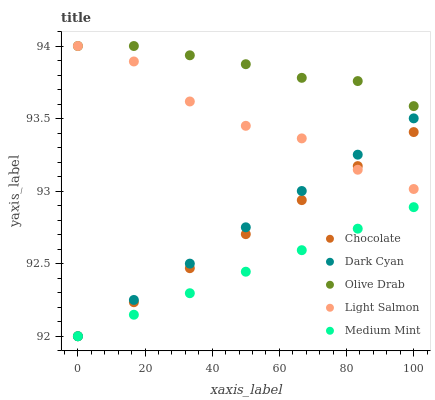Does Medium Mint have the minimum area under the curve?
Answer yes or no. Yes. Does Olive Drab have the maximum area under the curve?
Answer yes or no. Yes. Does Light Salmon have the minimum area under the curve?
Answer yes or no. No. Does Light Salmon have the maximum area under the curve?
Answer yes or no. No. Is Chocolate the smoothest?
Answer yes or no. Yes. Is Light Salmon the roughest?
Answer yes or no. Yes. Is Medium Mint the smoothest?
Answer yes or no. No. Is Medium Mint the roughest?
Answer yes or no. No. Does Dark Cyan have the lowest value?
Answer yes or no. Yes. Does Light Salmon have the lowest value?
Answer yes or no. No. Does Olive Drab have the highest value?
Answer yes or no. Yes. Does Medium Mint have the highest value?
Answer yes or no. No. Is Chocolate less than Olive Drab?
Answer yes or no. Yes. Is Olive Drab greater than Chocolate?
Answer yes or no. Yes. Does Olive Drab intersect Light Salmon?
Answer yes or no. Yes. Is Olive Drab less than Light Salmon?
Answer yes or no. No. Is Olive Drab greater than Light Salmon?
Answer yes or no. No. Does Chocolate intersect Olive Drab?
Answer yes or no. No. 